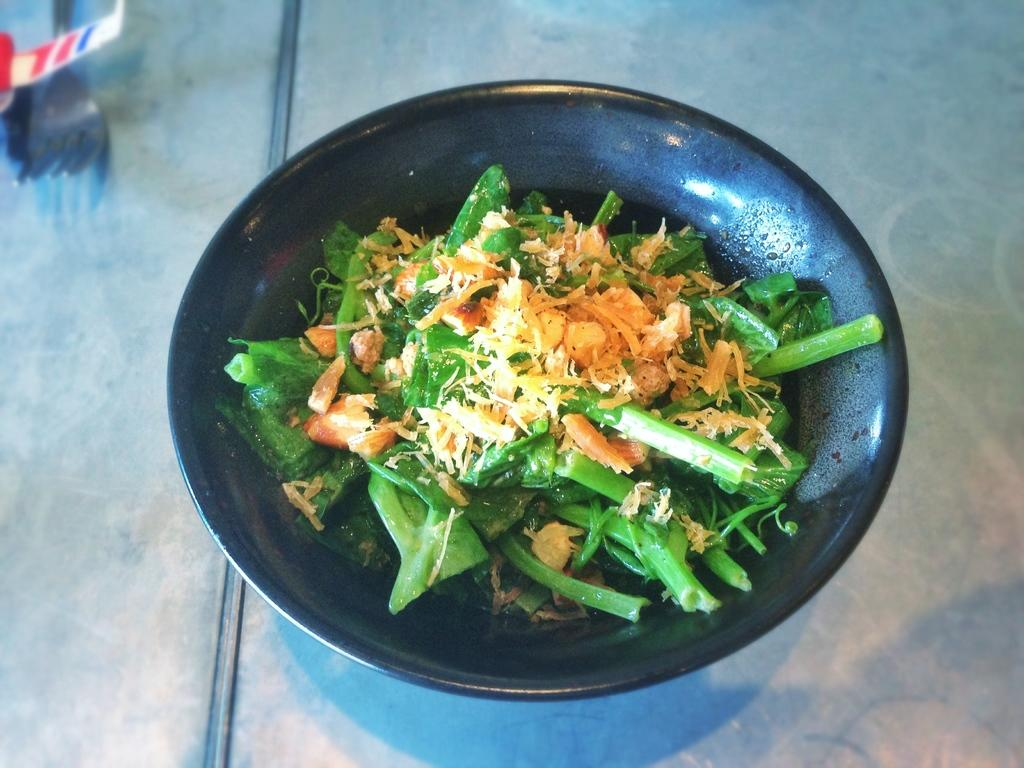What is the main subject of the image? There is a food item in a bowl in the image. Can you describe the objects on the left side of the image? Unfortunately, the provided facts do not mention any objects on the left side of the image. How many noses can be seen in the image? There are no noses visible in the image. What type of dust is present in the image? There is no mention of dust in the image, so it cannot be determined if any type of dust is present. 